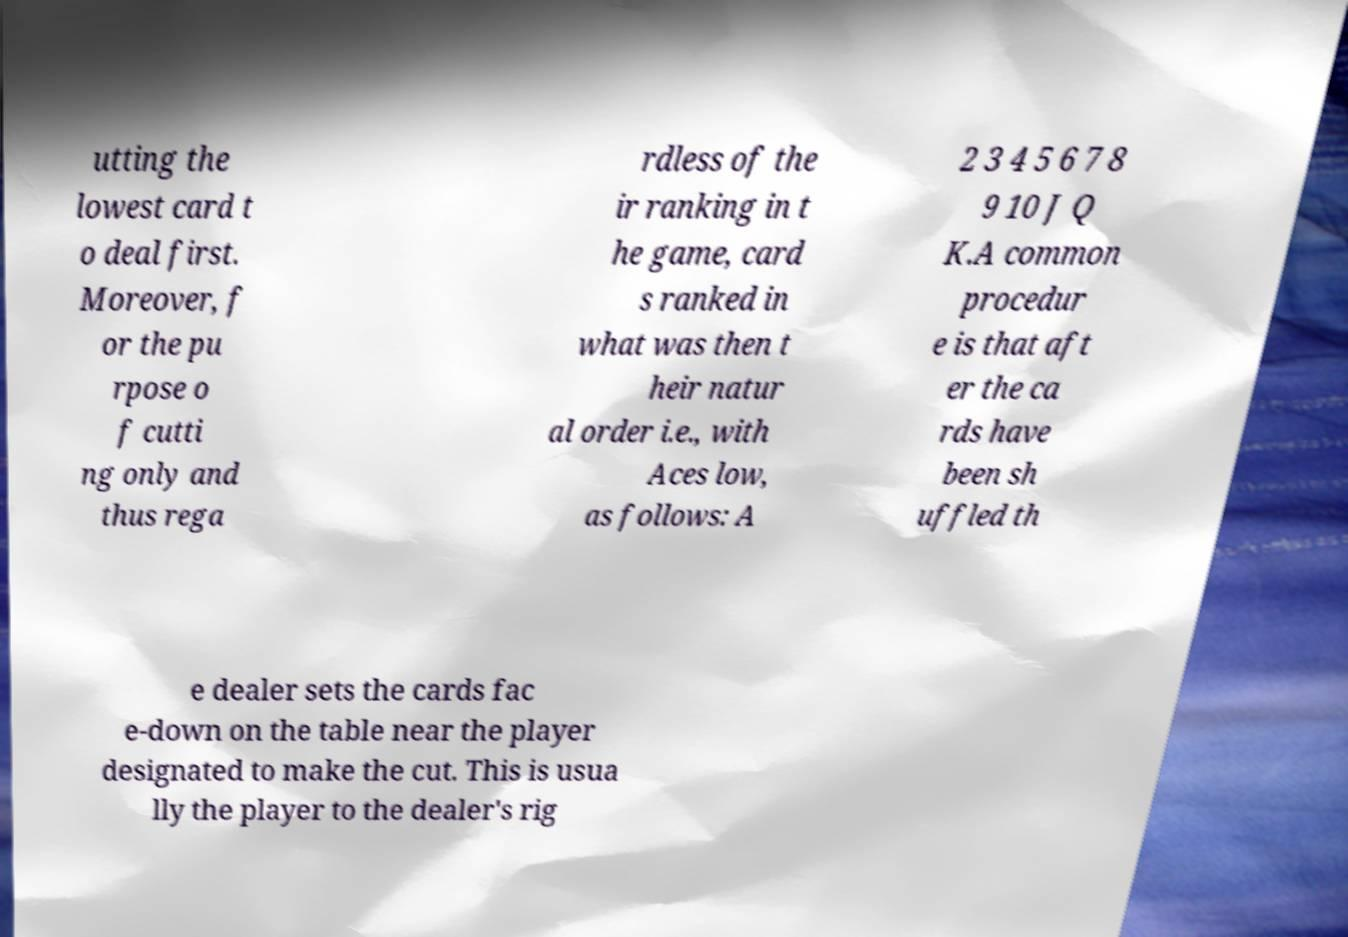Could you assist in decoding the text presented in this image and type it out clearly? utting the lowest card t o deal first. Moreover, f or the pu rpose o f cutti ng only and thus rega rdless of the ir ranking in t he game, card s ranked in what was then t heir natur al order i.e., with Aces low, as follows: A 2 3 4 5 6 7 8 9 10 J Q K.A common procedur e is that aft er the ca rds have been sh uffled th e dealer sets the cards fac e-down on the table near the player designated to make the cut. This is usua lly the player to the dealer's rig 